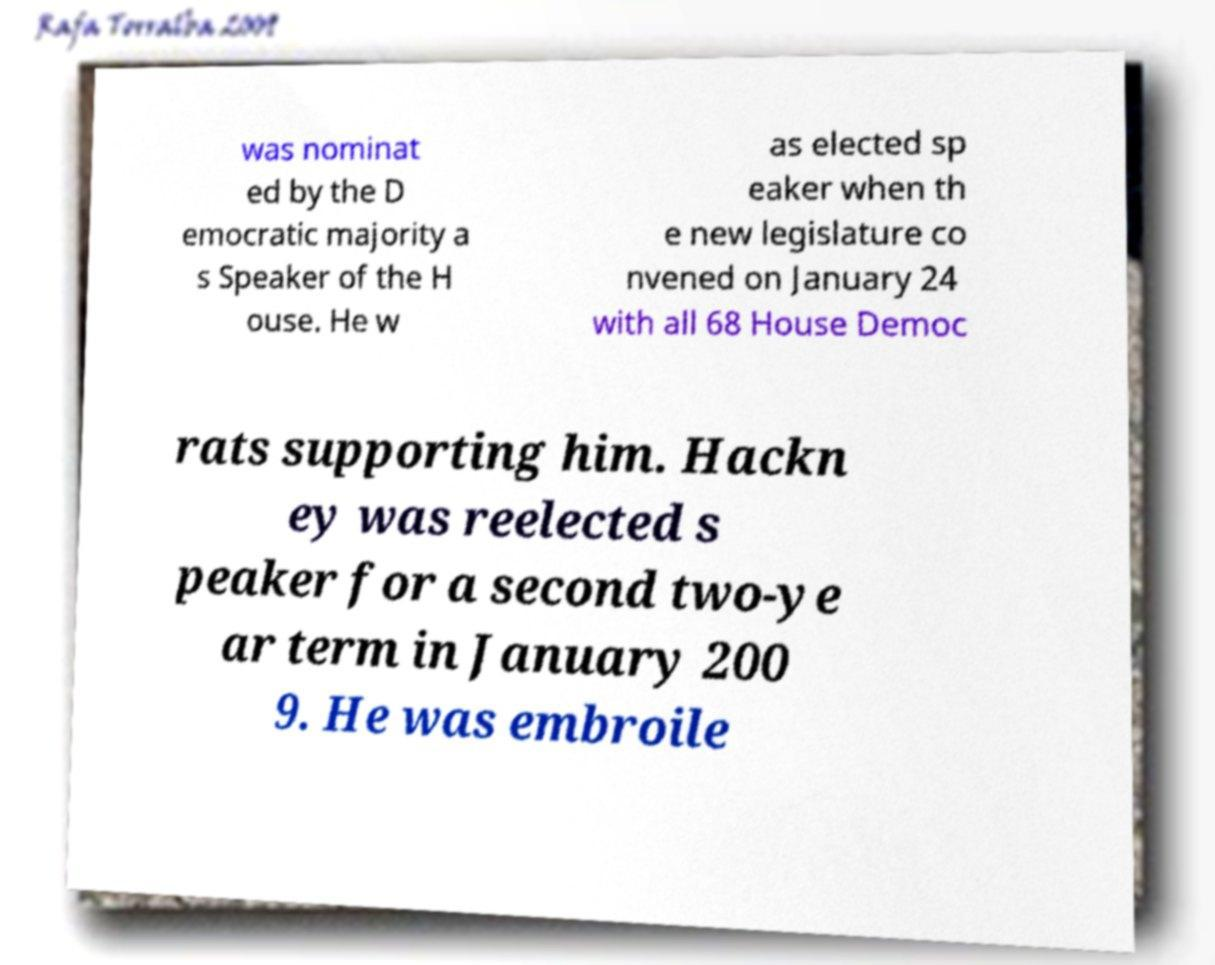Could you assist in decoding the text presented in this image and type it out clearly? was nominat ed by the D emocratic majority a s Speaker of the H ouse. He w as elected sp eaker when th e new legislature co nvened on January 24 with all 68 House Democ rats supporting him. Hackn ey was reelected s peaker for a second two-ye ar term in January 200 9. He was embroile 